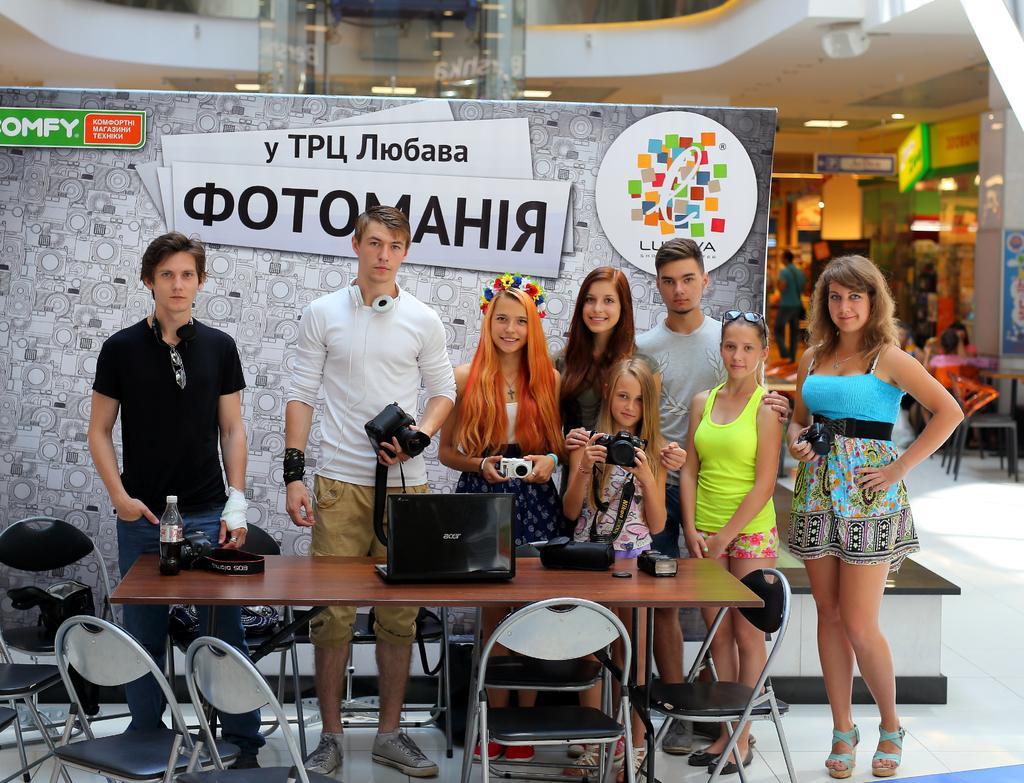In one or two sentences, can you explain what this image depicts? In the picture I can see a group of people are standing in front of a table. Some of them are holding cameras in hands. On the table I can see a laptop, a bottle and some other objects. Here I can see chairs. In the background I can see boards, lights on the ceiling, people some them some are standing and some are sitting on chairs and some other objects. 